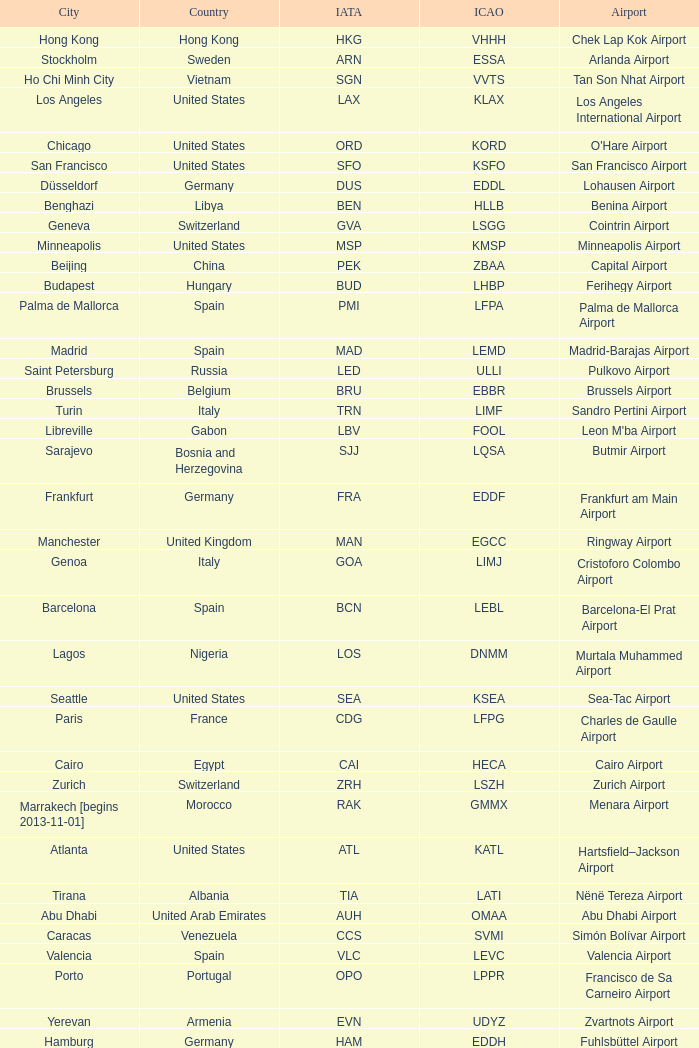What is the IATA for Ringway Airport in the United Kingdom? MAN. 